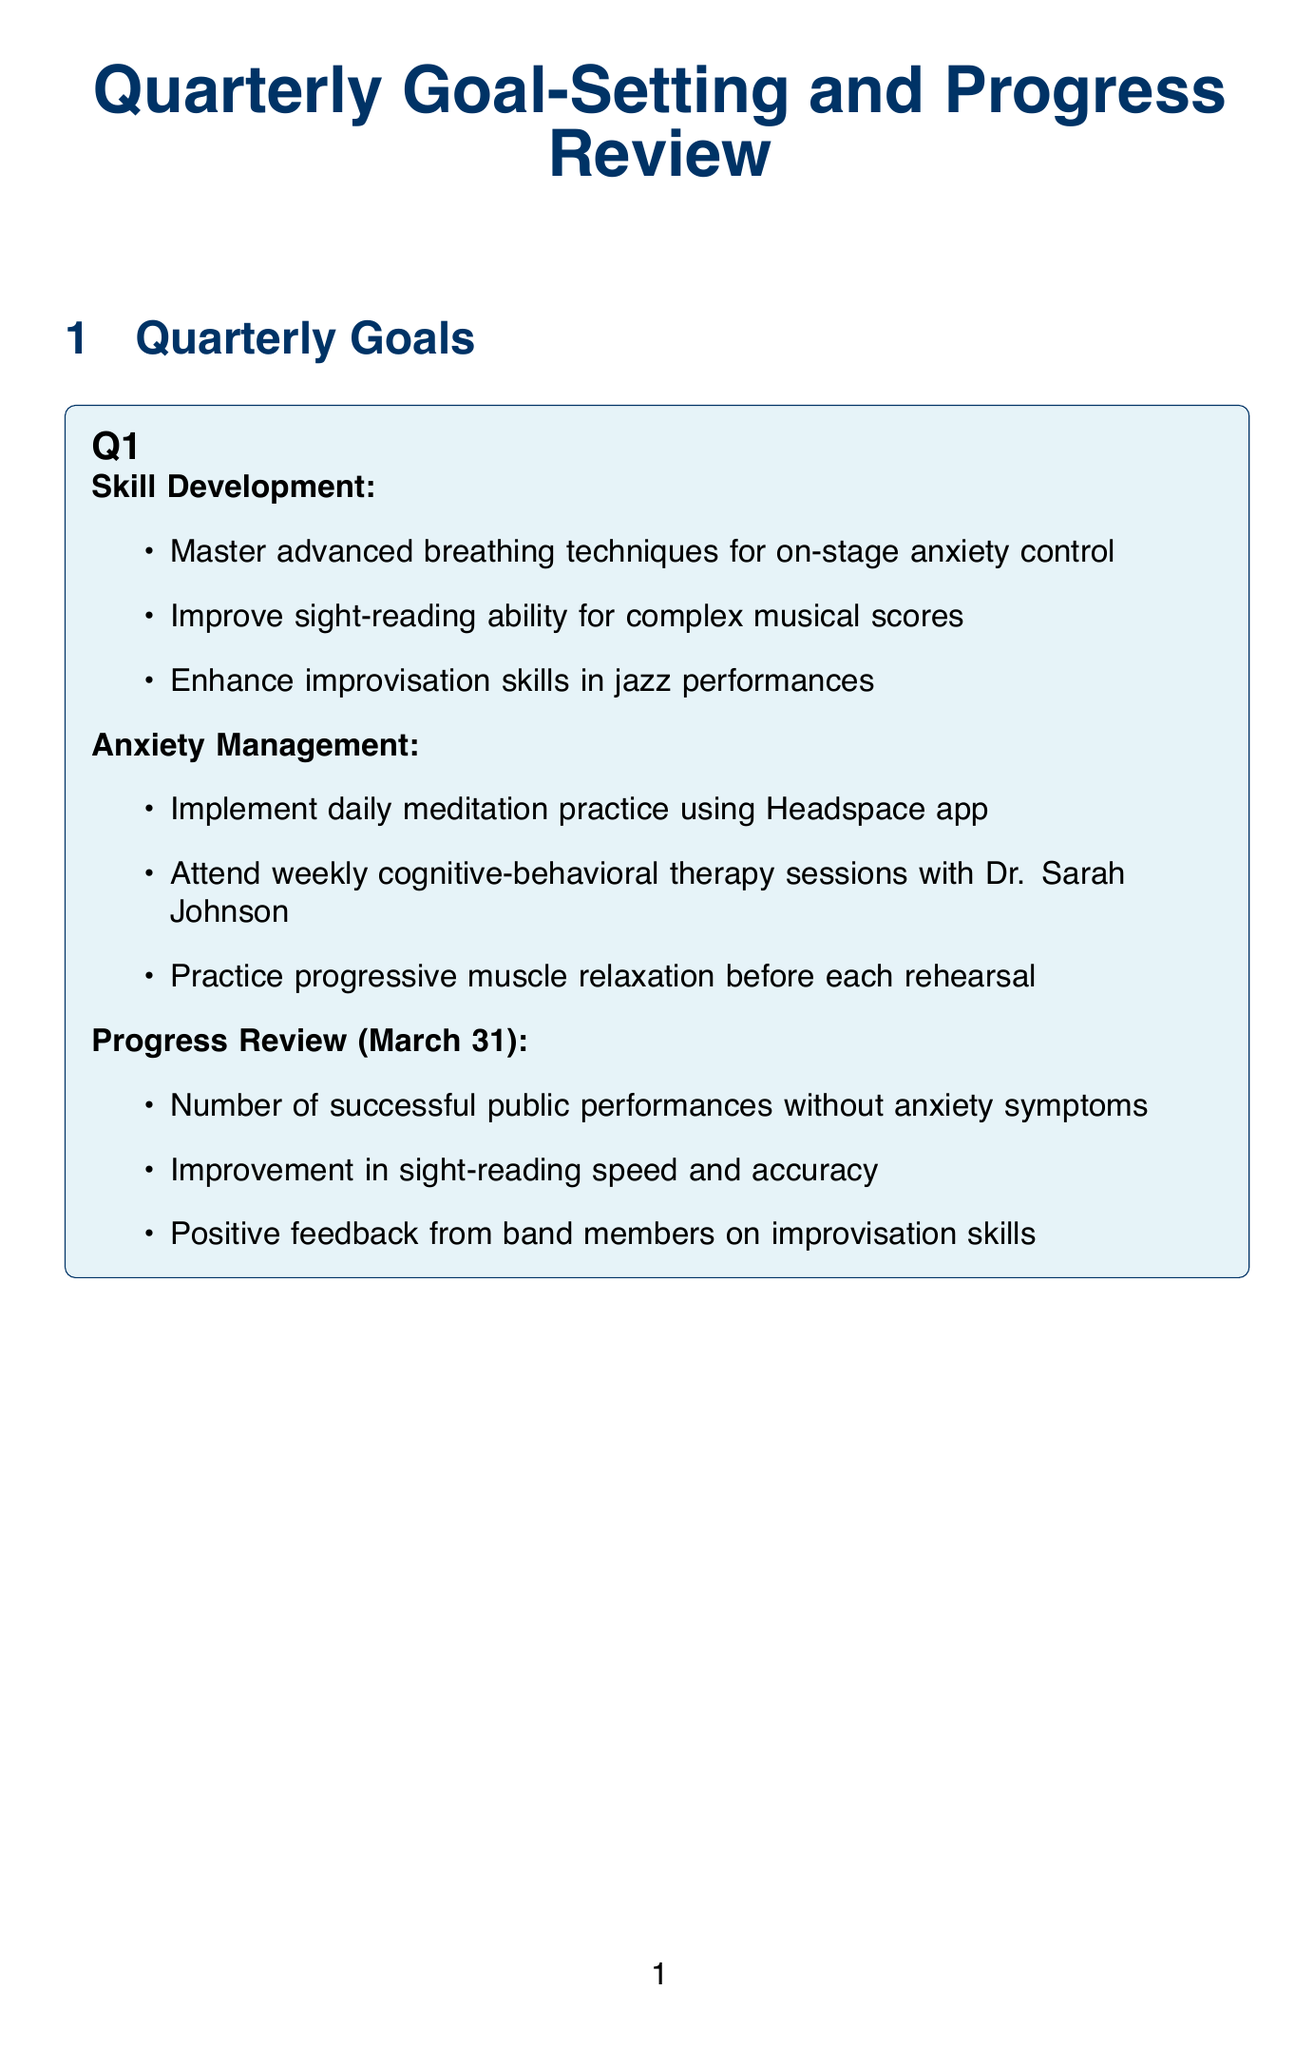What is the primary focus of Q1 skill development? The primary focus for Q1 skill development includes advanced breathing techniques, sight-reading, and improvisation.
Answer: Advanced breathing techniques for on-stage anxiety control What anxiety management practice is scheduled weekly in Q1? Q1 includes attending weekly cognitive-behavioral therapy sessions for anxiety management.
Answer: Weekly cognitive-behavioral therapy sessions When is the progress review for Q2 scheduled? The progress review date for Q2 is specified in the document as June 30.
Answer: June 30 What three new pieces are to be learned in Q2? The specific pieces to be learned from the Chopin Etudes involve three challenging works.
Answer: Three new challenging pieces from the Chopin Etudes What is one metric to assess progress in Q3? The metrics listed for assessing progress in Q3 include reduction in memory slips during performances.
Answer: Reduction in memory slips during performances Which tool is used for meditation and mindfulness? The document lists Headspace as the tool for meditation and mindfulness practices.
Answer: Headspace What type of workshop is attended in Q3? The document indicates a workshop focused on performance anxiety management at The Juilliard School is attended in Q3.
Answer: Workshop on performance anxiety management What is one way to manage anxiety in Q4? One of the anxiety management techniques in Q4 is through biofeedback training.
Answer: Biofeedback training using the HeartMath Inner Balance sensor How is the success of social media promotion assessed? The growth in social media following and engagement rates are metrics used for assessment in Q4.
Answer: Growth in social media following and engagement rates 